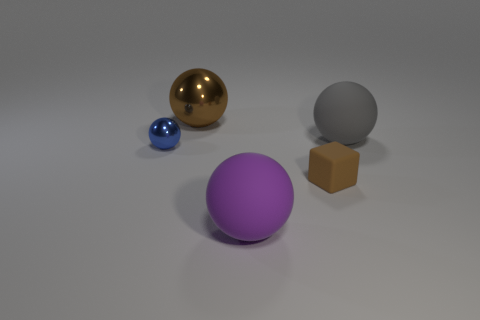Add 3 small metal things. How many objects exist? 8 Subtract all purple balls. How many balls are left? 3 Subtract all balls. How many objects are left? 1 Subtract 2 balls. How many balls are left? 2 Subtract all purple spheres. How many spheres are left? 3 Subtract 0 gray cylinders. How many objects are left? 5 Subtract all cyan balls. Subtract all purple blocks. How many balls are left? 4 Subtract all purple cylinders. How many purple spheres are left? 1 Subtract all small brown matte blocks. Subtract all big cyan rubber cylinders. How many objects are left? 4 Add 2 small blue things. How many small blue things are left? 3 